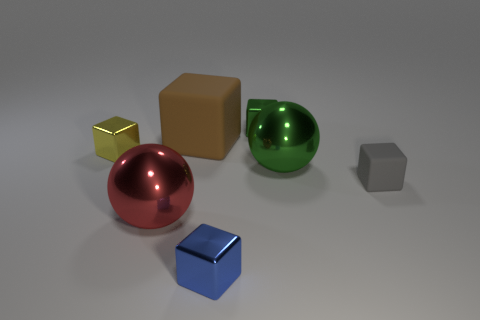There is a tiny metal object that is left of the metal cube in front of the large red thing; what color is it?
Ensure brevity in your answer.  Yellow. Are there any large matte things that have the same color as the big rubber cube?
Your answer should be compact. No. There is a shiny thing that is in front of the big shiny ball to the left of the metal thing that is in front of the large red sphere; how big is it?
Provide a succinct answer. Small. There is a red thing; is its shape the same as the large metal object that is right of the red metal object?
Offer a terse response. Yes. What number of other things are the same size as the brown block?
Your answer should be compact. 2. There is a green metallic thing in front of the small yellow metal object; what size is it?
Provide a short and direct response. Large. What number of big green things are the same material as the red sphere?
Offer a very short reply. 1. There is a large shiny thing to the right of the red thing; is it the same shape as the big red metal object?
Your answer should be very brief. Yes. What is the shape of the matte object to the left of the gray cube?
Provide a succinct answer. Cube. What material is the big cube?
Provide a succinct answer. Rubber. 